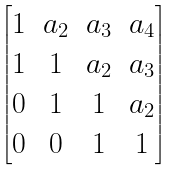<formula> <loc_0><loc_0><loc_500><loc_500>\begin{bmatrix} 1 & a _ { 2 } & a _ { 3 } & a _ { 4 } \\ 1 & 1 & a _ { 2 } & a _ { 3 } \\ 0 & 1 & 1 & a _ { 2 } \\ 0 & 0 & 1 & 1 \end{bmatrix}</formula> 